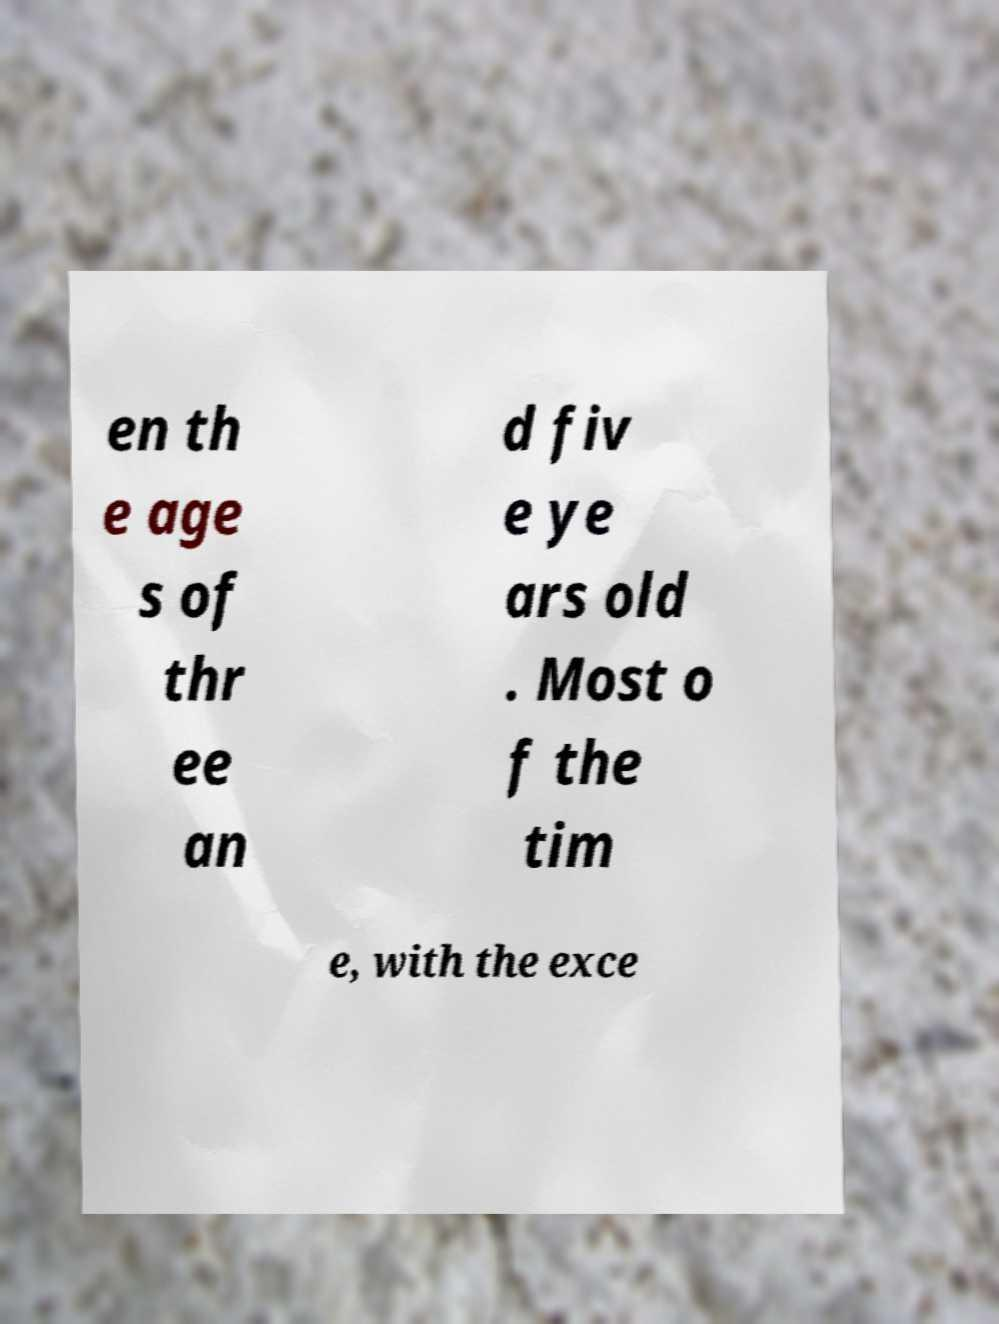Could you assist in decoding the text presented in this image and type it out clearly? en th e age s of thr ee an d fiv e ye ars old . Most o f the tim e, with the exce 